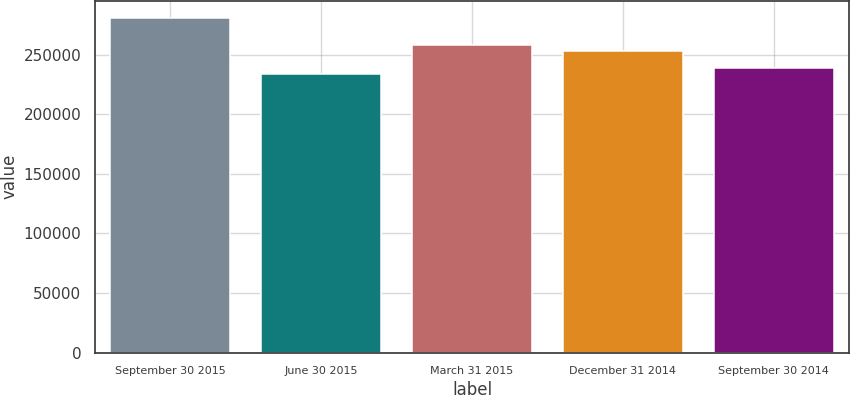<chart> <loc_0><loc_0><loc_500><loc_500><bar_chart><fcel>September 30 2015<fcel>June 30 2015<fcel>March 31 2015<fcel>December 31 2014<fcel>September 30 2014<nl><fcel>280934<fcel>233451<fcel>257729<fcel>252981<fcel>238841<nl></chart> 